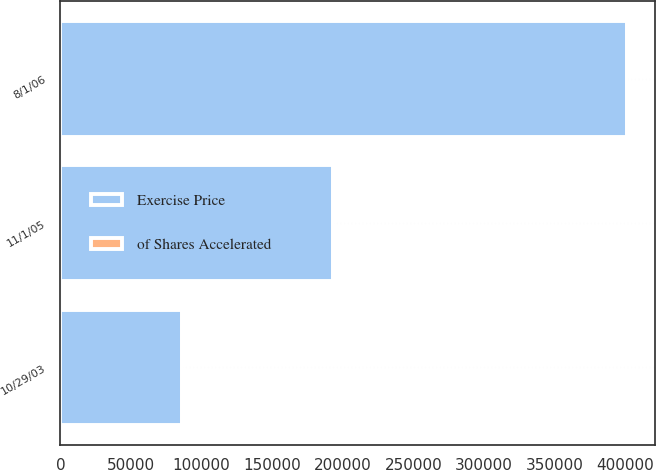Convert chart to OTSL. <chart><loc_0><loc_0><loc_500><loc_500><stacked_bar_chart><ecel><fcel>10/29/03<fcel>11/1/05<fcel>8/1/06<nl><fcel>of Shares Accelerated<fcel>15.87<fcel>23.46<fcel>17.94<nl><fcel>Exercise Price<fcel>86340<fcel>192650<fcel>400813<nl></chart> 